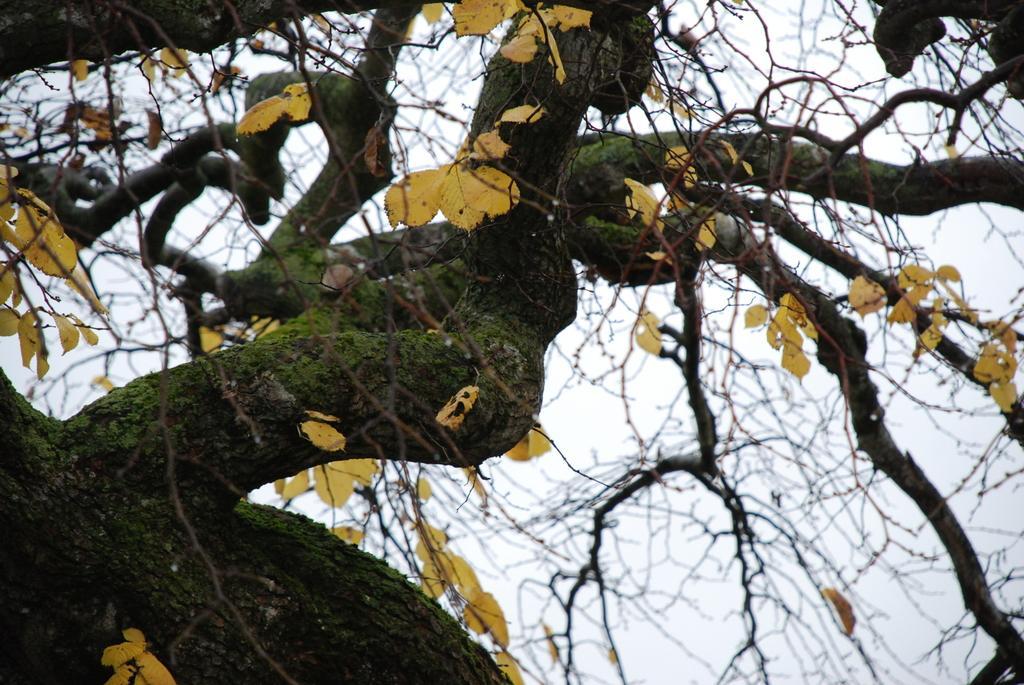How would you summarize this image in a sentence or two? In the image there is a tree with yellow color leaves and algae over it and above its sky. 